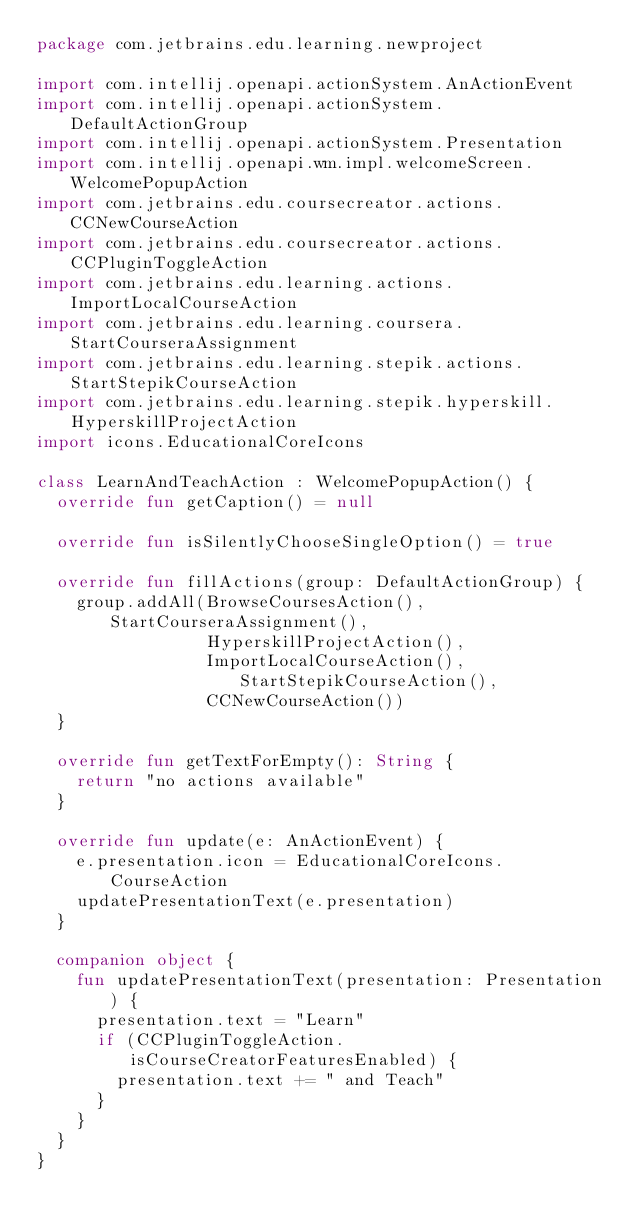Convert code to text. <code><loc_0><loc_0><loc_500><loc_500><_Kotlin_>package com.jetbrains.edu.learning.newproject

import com.intellij.openapi.actionSystem.AnActionEvent
import com.intellij.openapi.actionSystem.DefaultActionGroup
import com.intellij.openapi.actionSystem.Presentation
import com.intellij.openapi.wm.impl.welcomeScreen.WelcomePopupAction
import com.jetbrains.edu.coursecreator.actions.CCNewCourseAction
import com.jetbrains.edu.coursecreator.actions.CCPluginToggleAction
import com.jetbrains.edu.learning.actions.ImportLocalCourseAction
import com.jetbrains.edu.learning.coursera.StartCourseraAssignment
import com.jetbrains.edu.learning.stepik.actions.StartStepikCourseAction
import com.jetbrains.edu.learning.stepik.hyperskill.HyperskillProjectAction
import icons.EducationalCoreIcons

class LearnAndTeachAction : WelcomePopupAction() {
  override fun getCaption() = null

  override fun isSilentlyChooseSingleOption() = true

  override fun fillActions(group: DefaultActionGroup) {
    group.addAll(BrowseCoursesAction(), StartCourseraAssignment(),
                 HyperskillProjectAction(),
                 ImportLocalCourseAction(), StartStepikCourseAction(),
                 CCNewCourseAction())
  }

  override fun getTextForEmpty(): String {
    return "no actions available"
  }

  override fun update(e: AnActionEvent) {
    e.presentation.icon = EducationalCoreIcons.CourseAction
    updatePresentationText(e.presentation)
  }

  companion object {
    fun updatePresentationText(presentation: Presentation) {
      presentation.text = "Learn"
      if (CCPluginToggleAction.isCourseCreatorFeaturesEnabled) {
        presentation.text += " and Teach"
      }
    }
  }
}</code> 